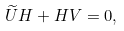Convert formula to latex. <formula><loc_0><loc_0><loc_500><loc_500>\widetilde { U } H + H V = 0 ,</formula> 